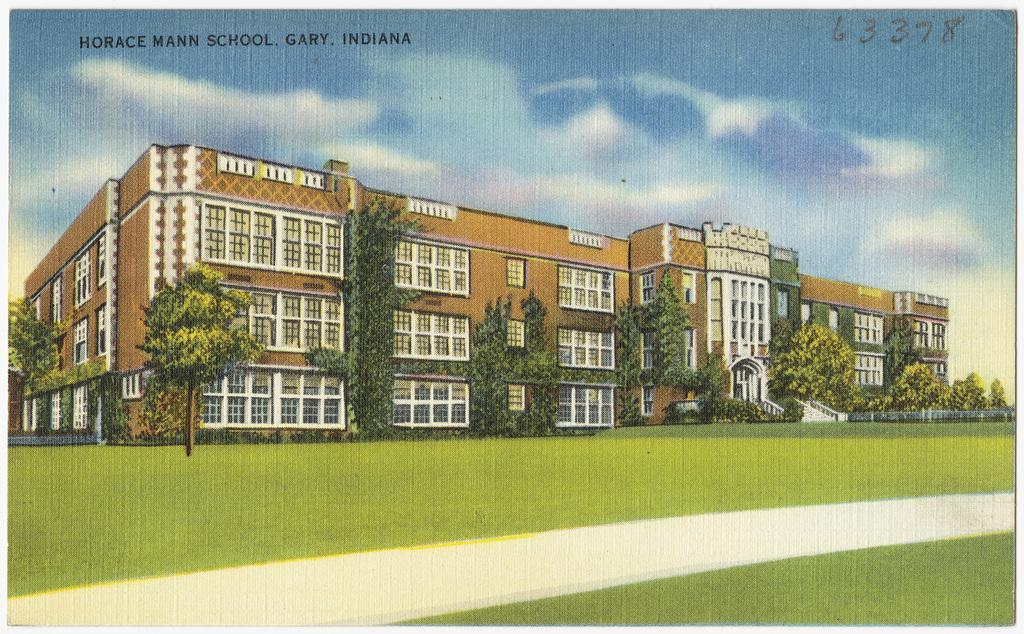What type of image is being described? The image is an animated picture. What type of structure can be seen in the image? There is a building in the image. What type of vegetation is present in the image? There is grass and trees in the image. What can be seen in the background of the image? The sky is visible in the background of the image. Is there any text or logo present in the image? Yes, there is a watermark in the image. Can you tell me how many hospitals are visible in the image? There are no hospitals visible in the image; it features an animated scene with a building, grass, trees, and a sky background. Is there any salt visible in the image? There is no salt present in the image. 